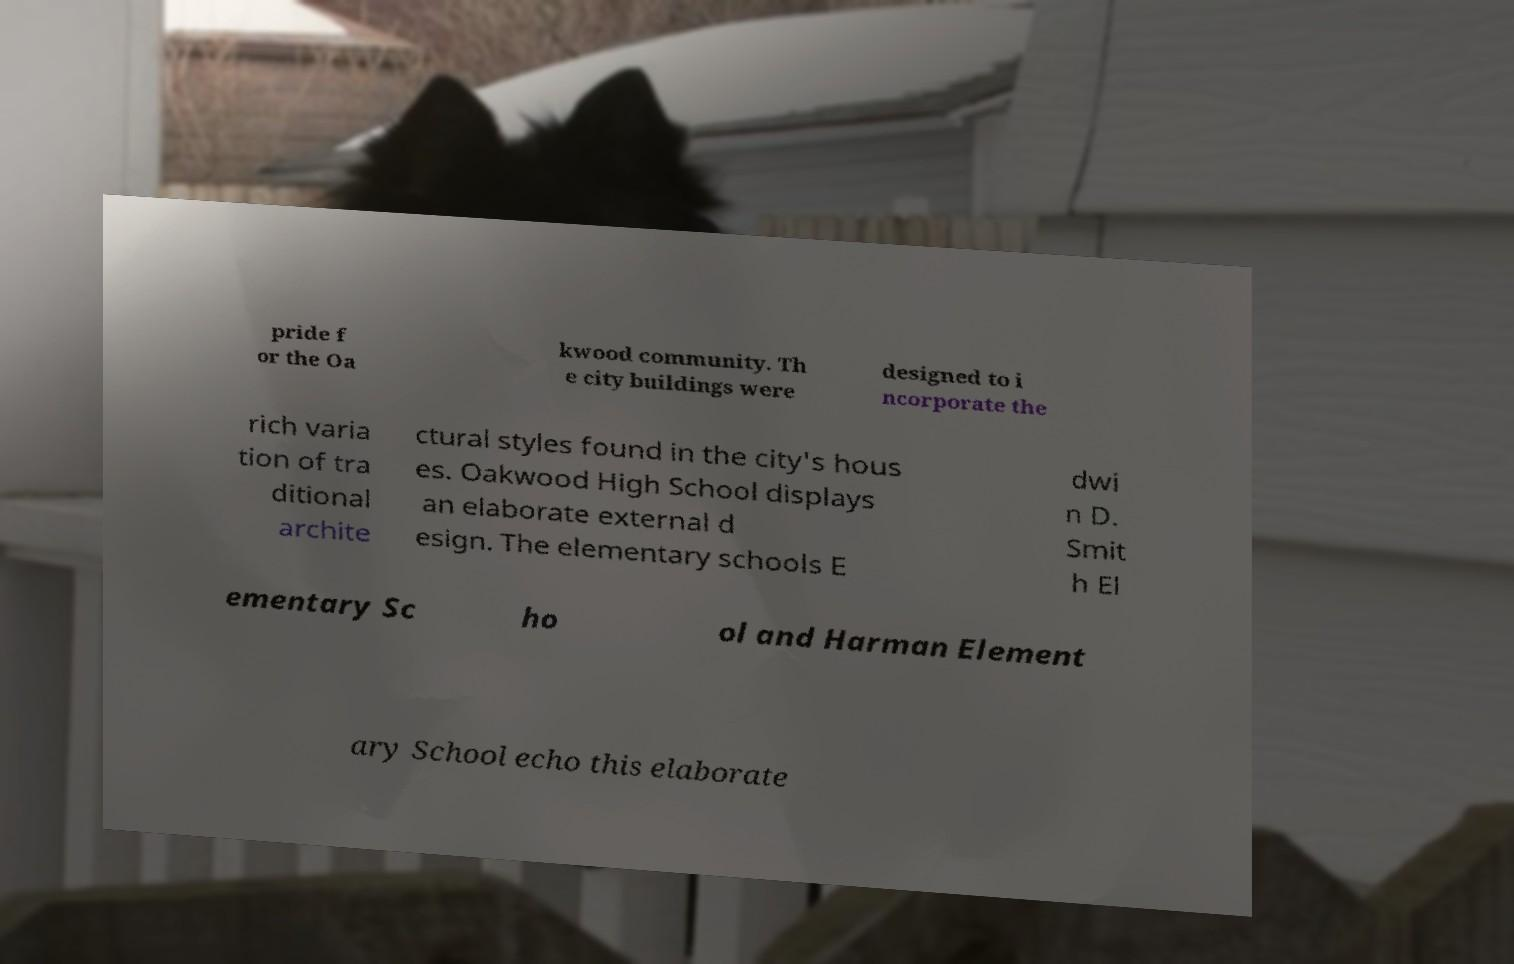Could you extract and type out the text from this image? pride f or the Oa kwood community. Th e city buildings were designed to i ncorporate the rich varia tion of tra ditional archite ctural styles found in the city's hous es. Oakwood High School displays an elaborate external d esign. The elementary schools E dwi n D. Smit h El ementary Sc ho ol and Harman Element ary School echo this elaborate 